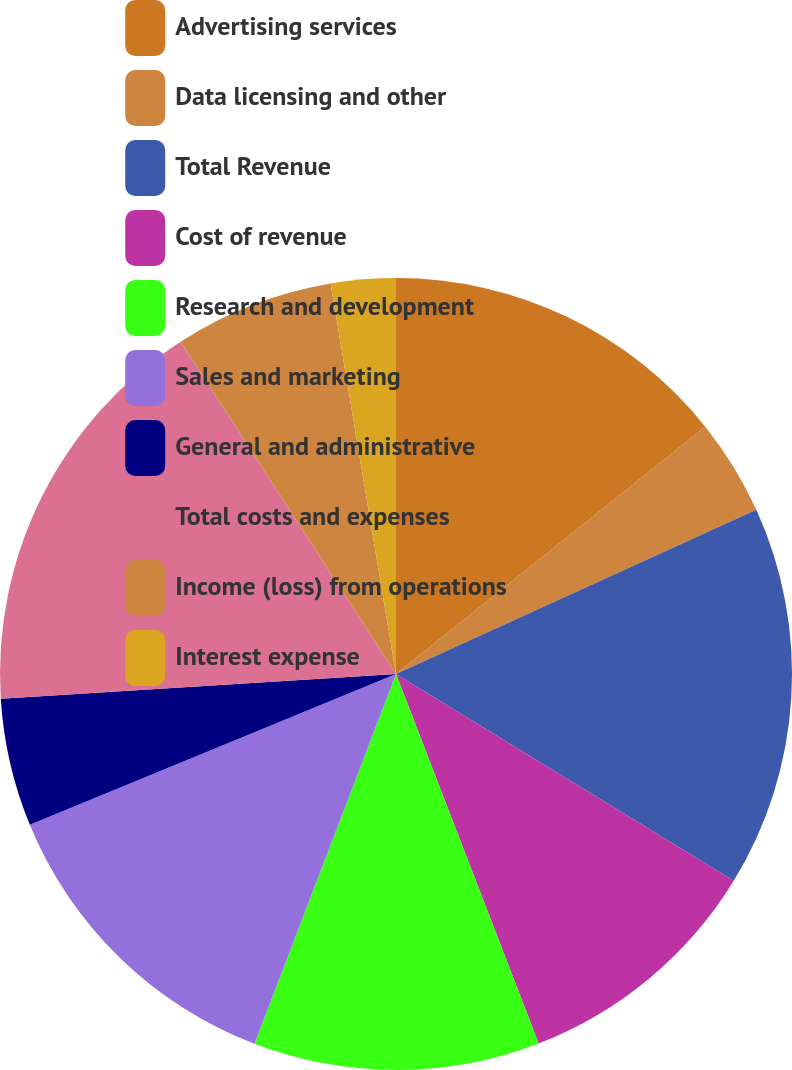Convert chart. <chart><loc_0><loc_0><loc_500><loc_500><pie_chart><fcel>Advertising services<fcel>Data licensing and other<fcel>Total Revenue<fcel>Cost of revenue<fcel>Research and development<fcel>Sales and marketing<fcel>General and administrative<fcel>Total costs and expenses<fcel>Income (loss) from operations<fcel>Interest expense<nl><fcel>14.26%<fcel>3.93%<fcel>15.55%<fcel>10.39%<fcel>11.68%<fcel>12.97%<fcel>5.22%<fcel>16.84%<fcel>6.51%<fcel>2.64%<nl></chart> 